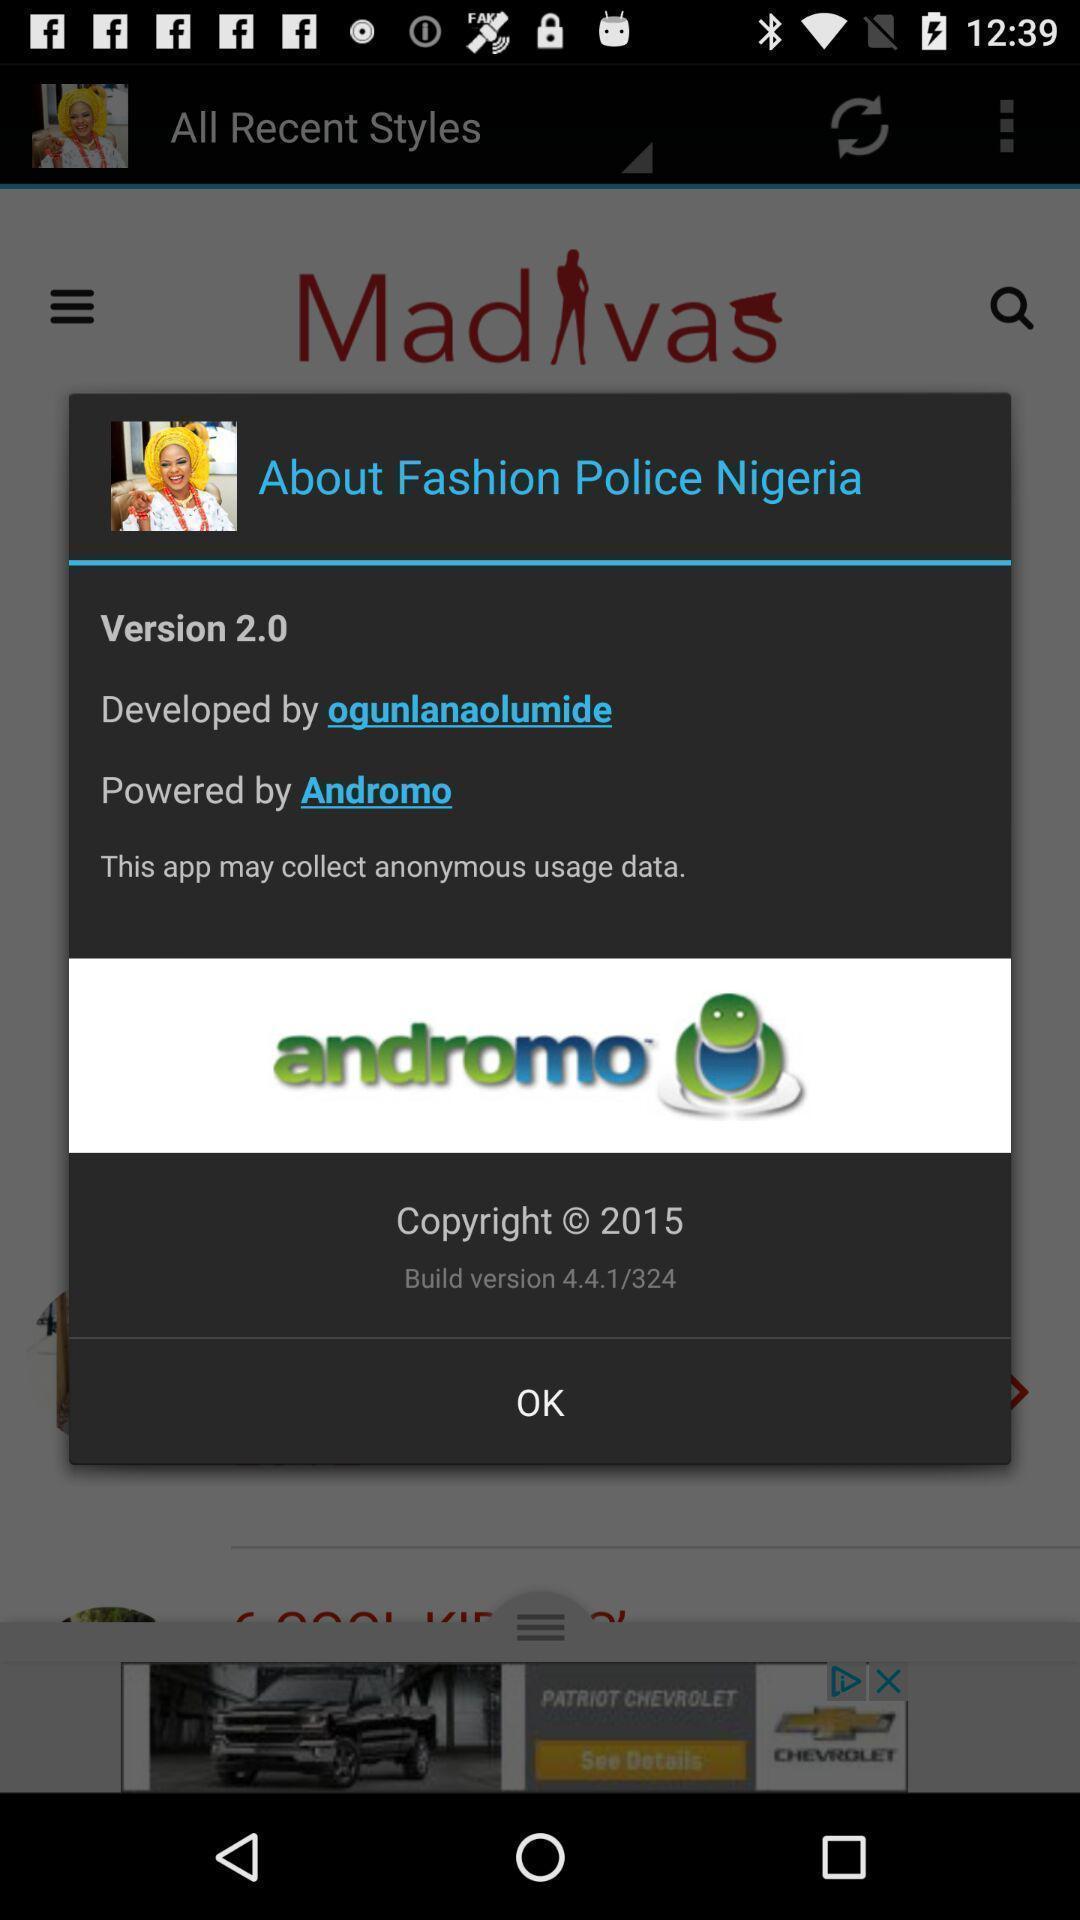Explain the elements present in this screenshot. Pop-up showing the 'about details for an app. 